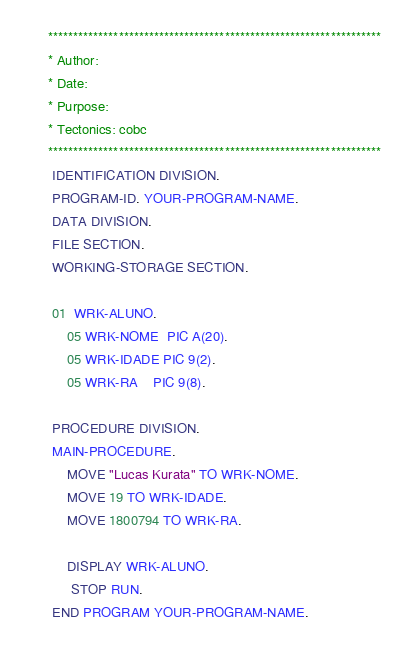Convert code to text. <code><loc_0><loc_0><loc_500><loc_500><_COBOL_>      ******************************************************************
      * Author:
      * Date:
      * Purpose:
      * Tectonics: cobc
      ******************************************************************
       IDENTIFICATION DIVISION.
       PROGRAM-ID. YOUR-PROGRAM-NAME.
       DATA DIVISION.
       FILE SECTION.
       WORKING-STORAGE SECTION.

       01  WRK-ALUNO.
           05 WRK-NOME  PIC A(20).
           05 WRK-IDADE PIC 9(2).
           05 WRK-RA    PIC 9(8).

       PROCEDURE DIVISION.
       MAIN-PROCEDURE.
           MOVE "Lucas Kurata" TO WRK-NOME.
           MOVE 19 TO WRK-IDADE.
           MOVE 1800794 TO WRK-RA.

           DISPLAY WRK-ALUNO.
            STOP RUN.
       END PROGRAM YOUR-PROGRAM-NAME.
</code> 